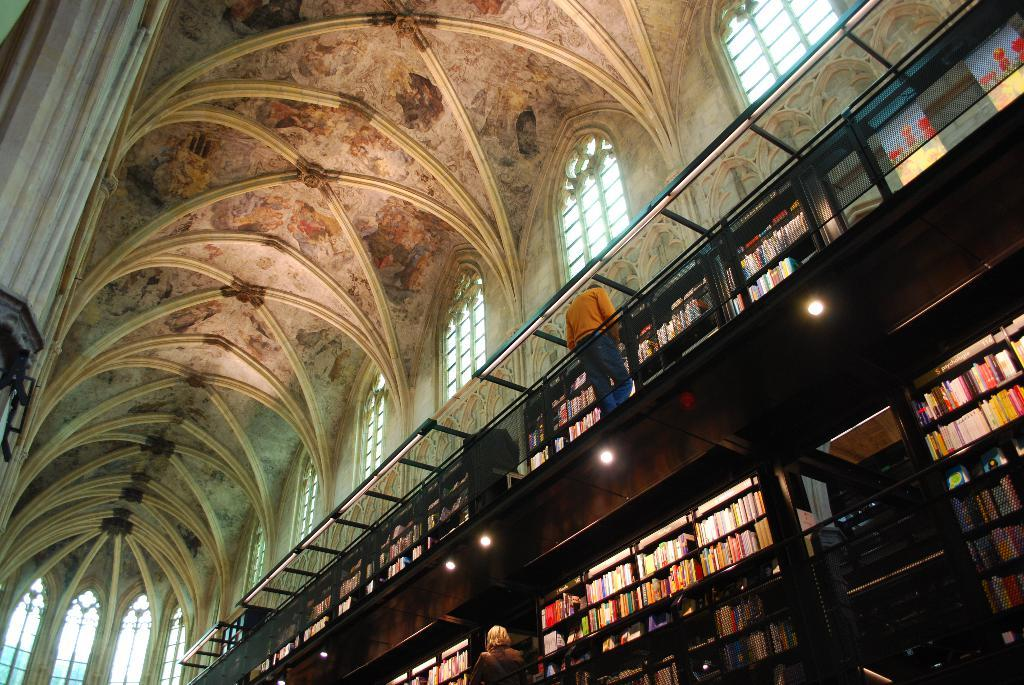What type of location is depicted in the image? The image shows an inside view of a building. Are there any people present in the image? Yes, there are people in the image. What can be seen illuminating the area in the image? There are lights visible in the image. What type of items can be seen stored in the building? There are books in racks in the image. What type of lunch is being served in the image? There is no lunch visible in the image; the focus is on the building, people, lights, and books in racks. Can you tell me who won the competition in the image? There is no competition present in the image; the focus is on the building, people, lights, and books in racks. 